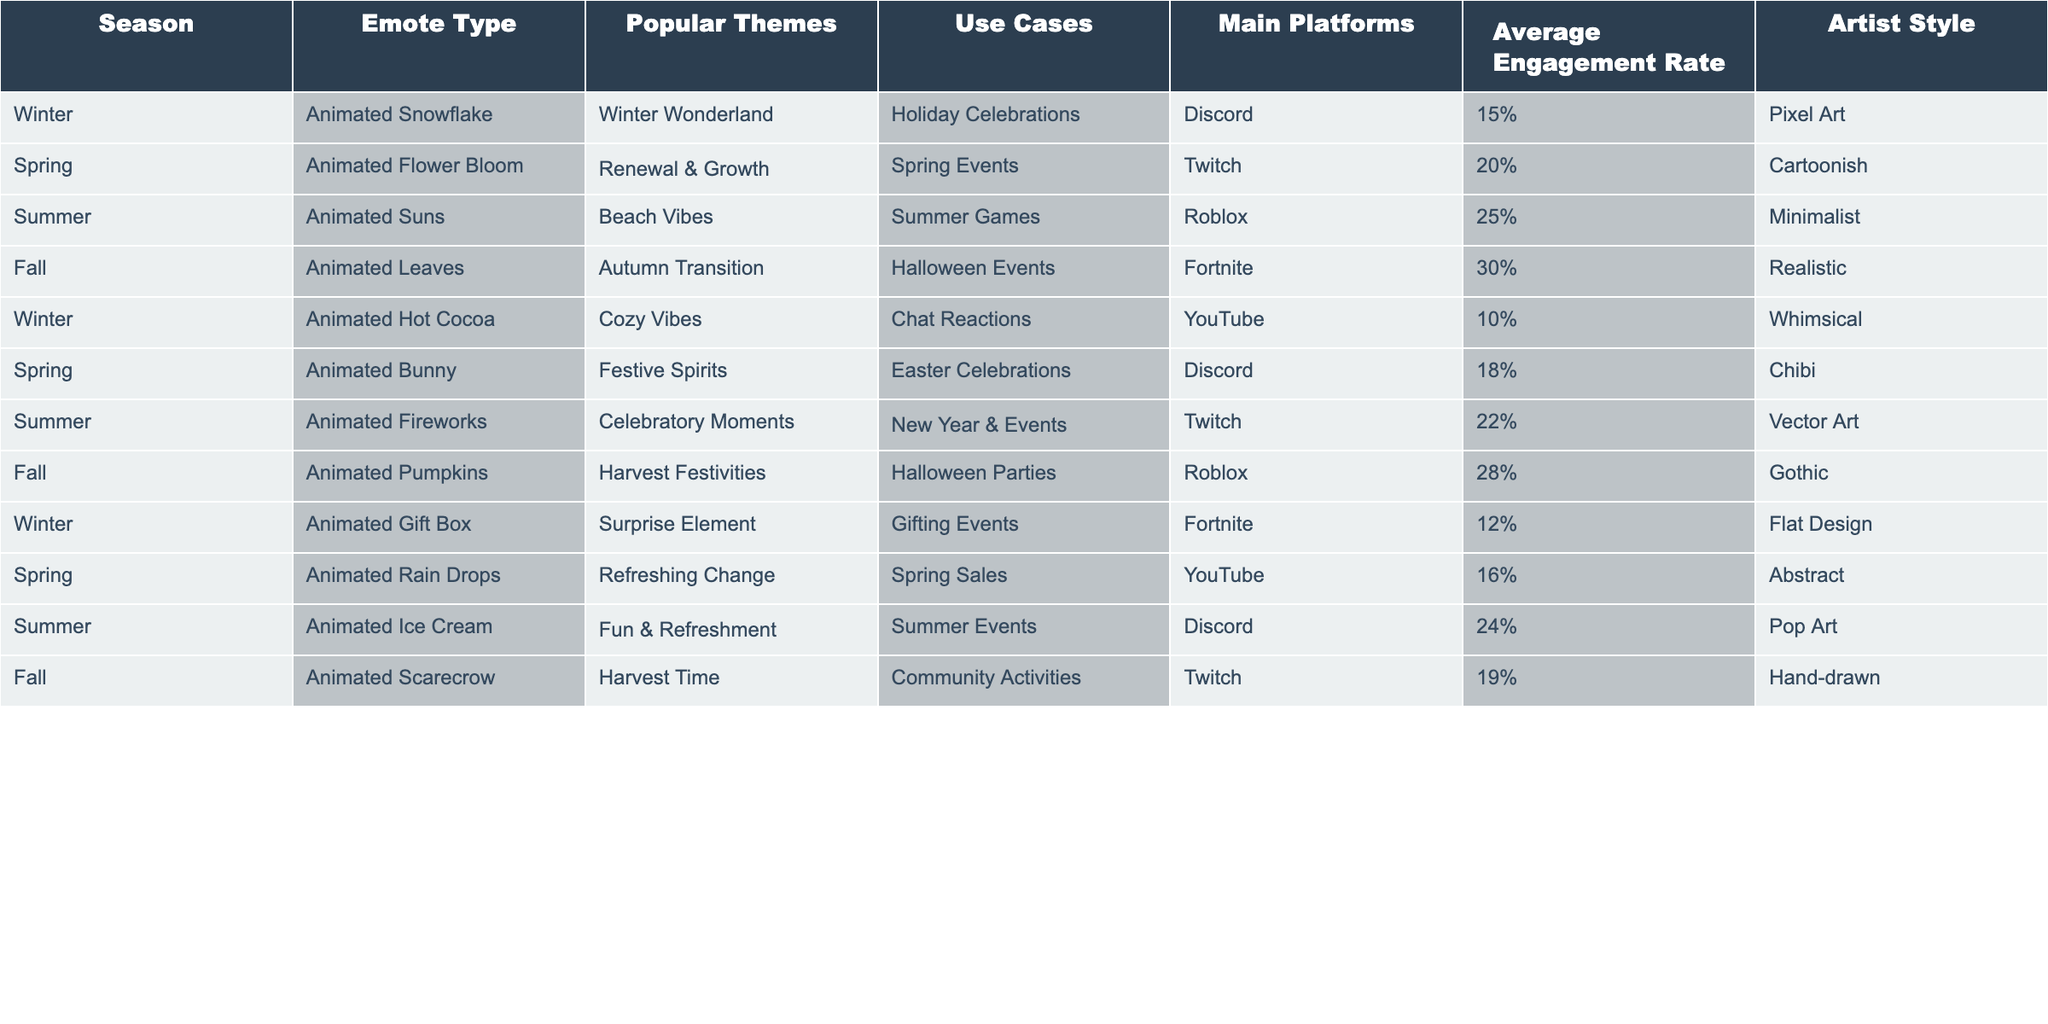What is the most popular emote type during Fall? The Fall season has two emote types listed: Animated Leaves and Animated Pumpkins. Among these, Animated Leaves is the only one explicitly stated with the highest engagement rate of 30%, making it the most popular in this season.
Answer: Animated Leaves Which emote has the lowest average engagement rate? In the data, the Animated Hot Cocoa emote from Winter has the lowest engagement rate listed at 10%. This is lower than any other emote across all seasons.
Answer: Animated Hot Cocoa What is the average engagement rate of animated emotes in Spring? There are three emotes in Spring: Animated Flower Bloom (20%), Animated Bunny (18%), and Animated Rain Drops (16%). To calculate the average, we first add these values: 20 + 18 + 16 = 54, then divide by the number of emotes (3), which gives us an average engagement rate of 54/3 = 18%.
Answer: 18% True or False: The Animated Gift Box is used in Halloween events. The Animated Gift Box is listed under Winter with use cases for Gifting Events. It does not appear in any Halloween-related events. Thus, this statement is false.
Answer: False What is the total engagement rate of Summer emotes? The Summer season has three emotes: Animated Suns (25%), Animated Fireworks (22%), and Animated Ice Cream (24%). Adding these values gives us: 25 + 22 + 24 = 71. Therefore, the total engagement rate of Summer emotes is 71%.
Answer: 71% Which main platform has the highest engagement rate for animated emotes? Examining the engagement rates for each main platform: Discord has two emotes (15% for Snowflake and 24% for Ice Cream), Twitch has three (20% for Flower Bloom, 22% for Fireworks, 19% for Scarecrow), Roblox has two (25% for Suns and 28% for Pumpkins), and YouTube has two (10% for Hot Cocoa and 16% for Rain Drops). The averages for Discord (19.5%), Twitch (20.33%), Roblox (26.5%), and YouTube (13%). The highest average engagement rate belongs to Roblox at 26.5%.
Answer: Roblox What two themes are most frequently associated with Fall emotes? In the Fall season, there are two emote types: Animated Leaves with the theme of Autumn Transition and Animated Pumpkins with the theme of Harvest Festivities. Therefore, the two themes most frequently associated with Fall emotes are Autumn Transition and Harvest Festivities.
Answer: Autumn Transition and Harvest Festivities Which artist style is associated with the highest engagement rate? To find this, we compare engagement rates across artist styles. The highest engagement rate noted is 30% for Realistic (Animated Leaves). Thus, the artist style with the highest engagement rate is Realistic.
Answer: Realistic 